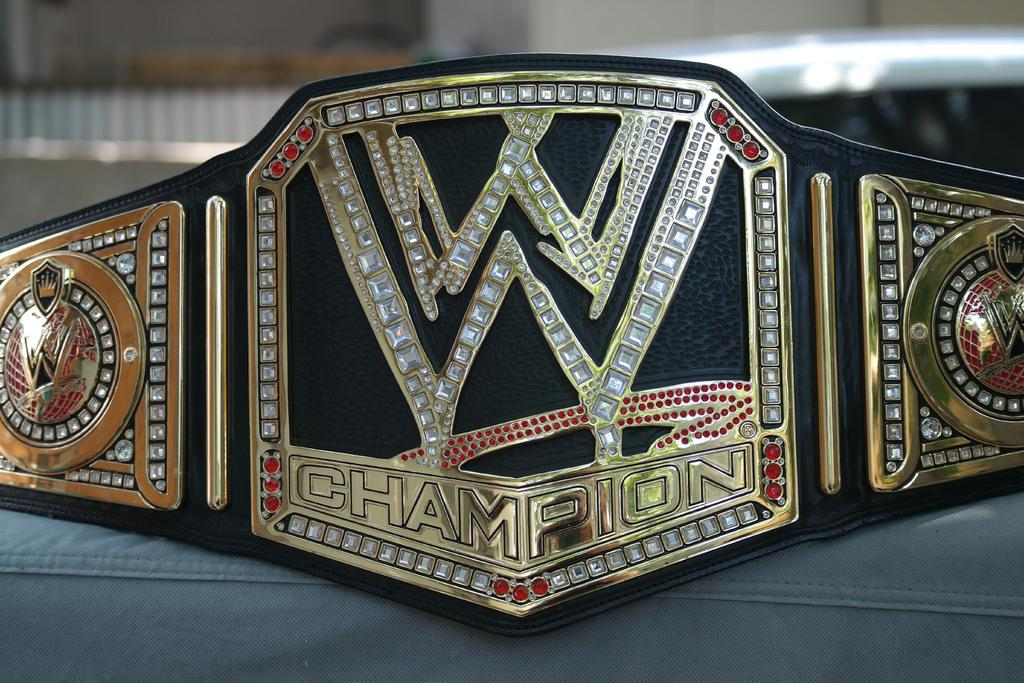What object can be seen in the image? There is a belt in the image. What colors are present on the belt? The belt is black and gold in color. Can you describe the background of the image? The background of the image is blurred. Is there a skate visible in the image? No, there is no skate present in the image. What type of form does the belt take in the image? The belt is a physical object, not a form, and it is visible in the image. 